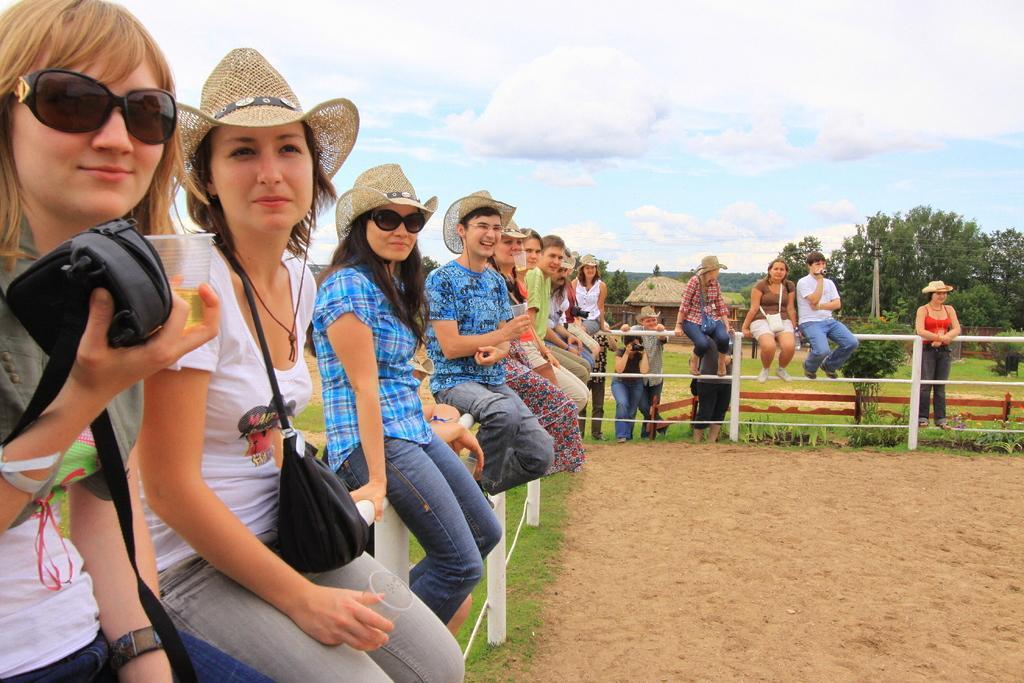Could you give a brief overview of what you see in this image? In the image we can see there are people wearing clothes and some of them are wearing caps and goggles. Some of them are carrying a handbag. Here we can see sand, grass, trees, electric poles and electric wires. We can even see hut, fence and the cloudy sky. 